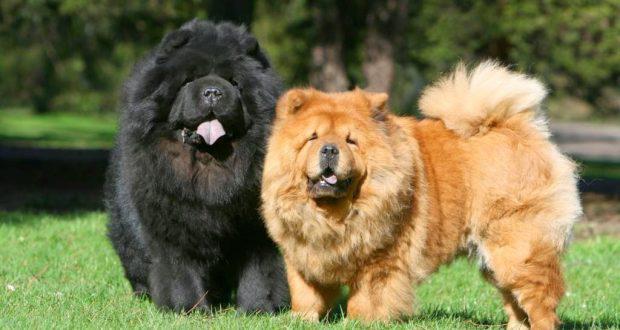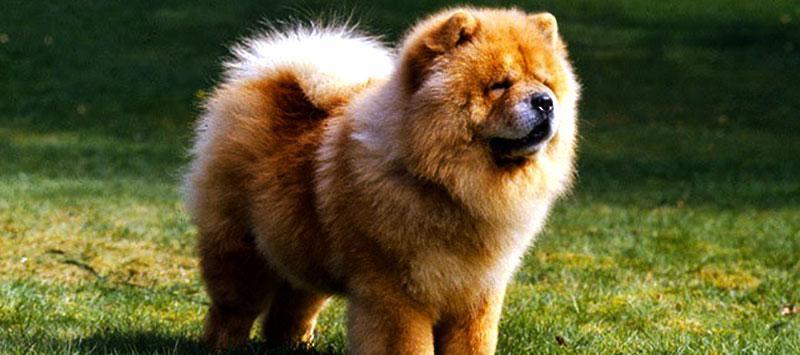The first image is the image on the left, the second image is the image on the right. Assess this claim about the two images: "The dog in the image on the right has its mouth open". Correct or not? Answer yes or no. No. 